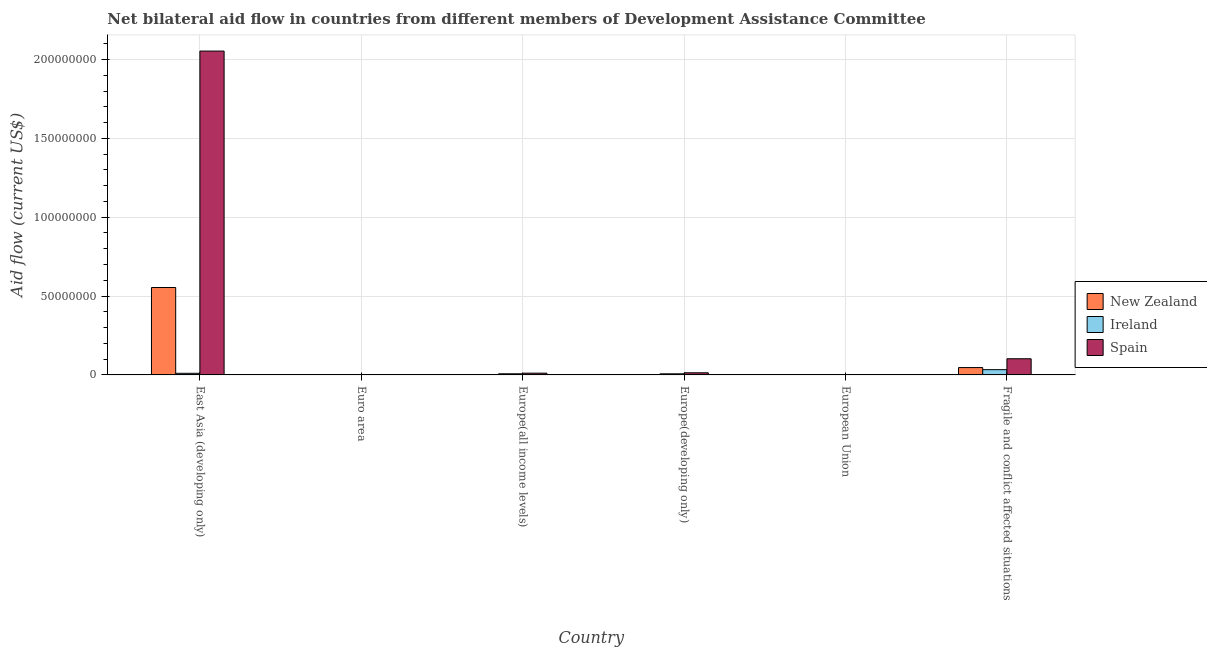How many different coloured bars are there?
Keep it short and to the point. 3. Are the number of bars per tick equal to the number of legend labels?
Make the answer very short. Yes. Are the number of bars on each tick of the X-axis equal?
Keep it short and to the point. Yes. How many bars are there on the 2nd tick from the left?
Your answer should be compact. 3. How many bars are there on the 4th tick from the right?
Ensure brevity in your answer.  3. What is the label of the 6th group of bars from the left?
Keep it short and to the point. Fragile and conflict affected situations. In how many cases, is the number of bars for a given country not equal to the number of legend labels?
Offer a very short reply. 0. What is the amount of aid provided by new zealand in Euro area?
Provide a succinct answer. 10000. Across all countries, what is the maximum amount of aid provided by new zealand?
Offer a terse response. 5.54e+07. Across all countries, what is the minimum amount of aid provided by ireland?
Make the answer very short. 3.00e+04. In which country was the amount of aid provided by new zealand maximum?
Your response must be concise. East Asia (developing only). In which country was the amount of aid provided by ireland minimum?
Provide a short and direct response. Euro area. What is the total amount of aid provided by spain in the graph?
Ensure brevity in your answer.  2.18e+08. What is the difference between the amount of aid provided by new zealand in East Asia (developing only) and that in European Union?
Provide a short and direct response. 5.54e+07. What is the difference between the amount of aid provided by ireland in Europe(developing only) and the amount of aid provided by spain in Fragile and conflict affected situations?
Your answer should be compact. -9.55e+06. What is the average amount of aid provided by new zealand per country?
Provide a succinct answer. 1.00e+07. What is the difference between the amount of aid provided by ireland and amount of aid provided by new zealand in Euro area?
Keep it short and to the point. 2.00e+04. What is the ratio of the amount of aid provided by spain in Europe(all income levels) to that in Fragile and conflict affected situations?
Offer a very short reply. 0.11. Is the amount of aid provided by ireland in European Union less than that in Fragile and conflict affected situations?
Your response must be concise. Yes. Is the difference between the amount of aid provided by spain in East Asia (developing only) and Fragile and conflict affected situations greater than the difference between the amount of aid provided by new zealand in East Asia (developing only) and Fragile and conflict affected situations?
Offer a very short reply. Yes. What is the difference between the highest and the second highest amount of aid provided by spain?
Keep it short and to the point. 1.95e+08. What is the difference between the highest and the lowest amount of aid provided by new zealand?
Offer a terse response. 5.54e+07. In how many countries, is the amount of aid provided by new zealand greater than the average amount of aid provided by new zealand taken over all countries?
Make the answer very short. 1. Is the sum of the amount of aid provided by ireland in Europe(all income levels) and Fragile and conflict affected situations greater than the maximum amount of aid provided by spain across all countries?
Provide a succinct answer. No. What does the 1st bar from the left in East Asia (developing only) represents?
Keep it short and to the point. New Zealand. What does the 3rd bar from the right in Europe(all income levels) represents?
Ensure brevity in your answer.  New Zealand. Are the values on the major ticks of Y-axis written in scientific E-notation?
Offer a terse response. No. Does the graph contain grids?
Your answer should be very brief. Yes. How many legend labels are there?
Ensure brevity in your answer.  3. What is the title of the graph?
Ensure brevity in your answer.  Net bilateral aid flow in countries from different members of Development Assistance Committee. Does "Private sector" appear as one of the legend labels in the graph?
Your answer should be compact. No. What is the Aid flow (current US$) of New Zealand in East Asia (developing only)?
Give a very brief answer. 5.54e+07. What is the Aid flow (current US$) of Ireland in East Asia (developing only)?
Provide a short and direct response. 1.02e+06. What is the Aid flow (current US$) in Spain in East Asia (developing only)?
Ensure brevity in your answer.  2.05e+08. What is the Aid flow (current US$) of Ireland in Euro area?
Ensure brevity in your answer.  3.00e+04. What is the Aid flow (current US$) of New Zealand in Europe(all income levels)?
Provide a short and direct response. 9.00e+04. What is the Aid flow (current US$) in Ireland in Europe(all income levels)?
Your answer should be compact. 7.20e+05. What is the Aid flow (current US$) of Spain in Europe(all income levels)?
Your answer should be compact. 1.11e+06. What is the Aid flow (current US$) in Ireland in Europe(developing only)?
Provide a succinct answer. 6.90e+05. What is the Aid flow (current US$) of Spain in Europe(developing only)?
Offer a terse response. 1.35e+06. What is the Aid flow (current US$) of New Zealand in European Union?
Give a very brief answer. 5.00e+04. What is the Aid flow (current US$) in New Zealand in Fragile and conflict affected situations?
Offer a very short reply. 4.66e+06. What is the Aid flow (current US$) of Ireland in Fragile and conflict affected situations?
Your answer should be very brief. 3.33e+06. What is the Aid flow (current US$) in Spain in Fragile and conflict affected situations?
Keep it short and to the point. 1.02e+07. Across all countries, what is the maximum Aid flow (current US$) in New Zealand?
Your answer should be compact. 5.54e+07. Across all countries, what is the maximum Aid flow (current US$) in Ireland?
Provide a short and direct response. 3.33e+06. Across all countries, what is the maximum Aid flow (current US$) of Spain?
Give a very brief answer. 2.05e+08. Across all countries, what is the minimum Aid flow (current US$) in Ireland?
Keep it short and to the point. 3.00e+04. Across all countries, what is the minimum Aid flow (current US$) in Spain?
Your response must be concise. 8.00e+04. What is the total Aid flow (current US$) of New Zealand in the graph?
Make the answer very short. 6.03e+07. What is the total Aid flow (current US$) of Ireland in the graph?
Give a very brief answer. 5.86e+06. What is the total Aid flow (current US$) of Spain in the graph?
Offer a terse response. 2.18e+08. What is the difference between the Aid flow (current US$) in New Zealand in East Asia (developing only) and that in Euro area?
Offer a very short reply. 5.54e+07. What is the difference between the Aid flow (current US$) in Ireland in East Asia (developing only) and that in Euro area?
Keep it short and to the point. 9.90e+05. What is the difference between the Aid flow (current US$) of Spain in East Asia (developing only) and that in Euro area?
Your response must be concise. 2.05e+08. What is the difference between the Aid flow (current US$) in New Zealand in East Asia (developing only) and that in Europe(all income levels)?
Offer a very short reply. 5.53e+07. What is the difference between the Aid flow (current US$) in Ireland in East Asia (developing only) and that in Europe(all income levels)?
Give a very brief answer. 3.00e+05. What is the difference between the Aid flow (current US$) in Spain in East Asia (developing only) and that in Europe(all income levels)?
Your answer should be very brief. 2.04e+08. What is the difference between the Aid flow (current US$) of New Zealand in East Asia (developing only) and that in Europe(developing only)?
Your answer should be very brief. 5.54e+07. What is the difference between the Aid flow (current US$) of Spain in East Asia (developing only) and that in Europe(developing only)?
Your response must be concise. 2.04e+08. What is the difference between the Aid flow (current US$) of New Zealand in East Asia (developing only) and that in European Union?
Keep it short and to the point. 5.54e+07. What is the difference between the Aid flow (current US$) in Ireland in East Asia (developing only) and that in European Union?
Your answer should be very brief. 9.50e+05. What is the difference between the Aid flow (current US$) in Spain in East Asia (developing only) and that in European Union?
Give a very brief answer. 2.05e+08. What is the difference between the Aid flow (current US$) in New Zealand in East Asia (developing only) and that in Fragile and conflict affected situations?
Your answer should be very brief. 5.08e+07. What is the difference between the Aid flow (current US$) of Ireland in East Asia (developing only) and that in Fragile and conflict affected situations?
Provide a short and direct response. -2.31e+06. What is the difference between the Aid flow (current US$) of Spain in East Asia (developing only) and that in Fragile and conflict affected situations?
Offer a very short reply. 1.95e+08. What is the difference between the Aid flow (current US$) of Ireland in Euro area and that in Europe(all income levels)?
Offer a very short reply. -6.90e+05. What is the difference between the Aid flow (current US$) of Spain in Euro area and that in Europe(all income levels)?
Make the answer very short. -9.10e+05. What is the difference between the Aid flow (current US$) of Ireland in Euro area and that in Europe(developing only)?
Offer a very short reply. -6.60e+05. What is the difference between the Aid flow (current US$) in Spain in Euro area and that in Europe(developing only)?
Your response must be concise. -1.15e+06. What is the difference between the Aid flow (current US$) of New Zealand in Euro area and that in European Union?
Your response must be concise. -4.00e+04. What is the difference between the Aid flow (current US$) of Ireland in Euro area and that in European Union?
Your answer should be compact. -4.00e+04. What is the difference between the Aid flow (current US$) of Spain in Euro area and that in European Union?
Provide a succinct answer. 1.20e+05. What is the difference between the Aid flow (current US$) in New Zealand in Euro area and that in Fragile and conflict affected situations?
Make the answer very short. -4.65e+06. What is the difference between the Aid flow (current US$) of Ireland in Euro area and that in Fragile and conflict affected situations?
Offer a very short reply. -3.30e+06. What is the difference between the Aid flow (current US$) in Spain in Euro area and that in Fragile and conflict affected situations?
Keep it short and to the point. -1.00e+07. What is the difference between the Aid flow (current US$) of Ireland in Europe(all income levels) and that in Europe(developing only)?
Your response must be concise. 3.00e+04. What is the difference between the Aid flow (current US$) of Ireland in Europe(all income levels) and that in European Union?
Make the answer very short. 6.50e+05. What is the difference between the Aid flow (current US$) of Spain in Europe(all income levels) and that in European Union?
Give a very brief answer. 1.03e+06. What is the difference between the Aid flow (current US$) of New Zealand in Europe(all income levels) and that in Fragile and conflict affected situations?
Your answer should be very brief. -4.57e+06. What is the difference between the Aid flow (current US$) of Ireland in Europe(all income levels) and that in Fragile and conflict affected situations?
Offer a terse response. -2.61e+06. What is the difference between the Aid flow (current US$) in Spain in Europe(all income levels) and that in Fragile and conflict affected situations?
Your response must be concise. -9.13e+06. What is the difference between the Aid flow (current US$) of Ireland in Europe(developing only) and that in European Union?
Your answer should be very brief. 6.20e+05. What is the difference between the Aid flow (current US$) of Spain in Europe(developing only) and that in European Union?
Provide a succinct answer. 1.27e+06. What is the difference between the Aid flow (current US$) in New Zealand in Europe(developing only) and that in Fragile and conflict affected situations?
Give a very brief answer. -4.60e+06. What is the difference between the Aid flow (current US$) in Ireland in Europe(developing only) and that in Fragile and conflict affected situations?
Offer a terse response. -2.64e+06. What is the difference between the Aid flow (current US$) of Spain in Europe(developing only) and that in Fragile and conflict affected situations?
Offer a very short reply. -8.89e+06. What is the difference between the Aid flow (current US$) in New Zealand in European Union and that in Fragile and conflict affected situations?
Keep it short and to the point. -4.61e+06. What is the difference between the Aid flow (current US$) of Ireland in European Union and that in Fragile and conflict affected situations?
Your answer should be compact. -3.26e+06. What is the difference between the Aid flow (current US$) in Spain in European Union and that in Fragile and conflict affected situations?
Keep it short and to the point. -1.02e+07. What is the difference between the Aid flow (current US$) in New Zealand in East Asia (developing only) and the Aid flow (current US$) in Ireland in Euro area?
Offer a very short reply. 5.54e+07. What is the difference between the Aid flow (current US$) in New Zealand in East Asia (developing only) and the Aid flow (current US$) in Spain in Euro area?
Make the answer very short. 5.52e+07. What is the difference between the Aid flow (current US$) of Ireland in East Asia (developing only) and the Aid flow (current US$) of Spain in Euro area?
Provide a succinct answer. 8.20e+05. What is the difference between the Aid flow (current US$) in New Zealand in East Asia (developing only) and the Aid flow (current US$) in Ireland in Europe(all income levels)?
Offer a very short reply. 5.47e+07. What is the difference between the Aid flow (current US$) in New Zealand in East Asia (developing only) and the Aid flow (current US$) in Spain in Europe(all income levels)?
Your answer should be compact. 5.43e+07. What is the difference between the Aid flow (current US$) in New Zealand in East Asia (developing only) and the Aid flow (current US$) in Ireland in Europe(developing only)?
Keep it short and to the point. 5.47e+07. What is the difference between the Aid flow (current US$) in New Zealand in East Asia (developing only) and the Aid flow (current US$) in Spain in Europe(developing only)?
Provide a short and direct response. 5.41e+07. What is the difference between the Aid flow (current US$) in Ireland in East Asia (developing only) and the Aid flow (current US$) in Spain in Europe(developing only)?
Keep it short and to the point. -3.30e+05. What is the difference between the Aid flow (current US$) in New Zealand in East Asia (developing only) and the Aid flow (current US$) in Ireland in European Union?
Provide a succinct answer. 5.54e+07. What is the difference between the Aid flow (current US$) of New Zealand in East Asia (developing only) and the Aid flow (current US$) of Spain in European Union?
Offer a very short reply. 5.54e+07. What is the difference between the Aid flow (current US$) of Ireland in East Asia (developing only) and the Aid flow (current US$) of Spain in European Union?
Offer a terse response. 9.40e+05. What is the difference between the Aid flow (current US$) of New Zealand in East Asia (developing only) and the Aid flow (current US$) of Ireland in Fragile and conflict affected situations?
Offer a very short reply. 5.21e+07. What is the difference between the Aid flow (current US$) in New Zealand in East Asia (developing only) and the Aid flow (current US$) in Spain in Fragile and conflict affected situations?
Provide a short and direct response. 4.52e+07. What is the difference between the Aid flow (current US$) of Ireland in East Asia (developing only) and the Aid flow (current US$) of Spain in Fragile and conflict affected situations?
Your answer should be very brief. -9.22e+06. What is the difference between the Aid flow (current US$) of New Zealand in Euro area and the Aid flow (current US$) of Ireland in Europe(all income levels)?
Ensure brevity in your answer.  -7.10e+05. What is the difference between the Aid flow (current US$) of New Zealand in Euro area and the Aid flow (current US$) of Spain in Europe(all income levels)?
Give a very brief answer. -1.10e+06. What is the difference between the Aid flow (current US$) in Ireland in Euro area and the Aid flow (current US$) in Spain in Europe(all income levels)?
Keep it short and to the point. -1.08e+06. What is the difference between the Aid flow (current US$) in New Zealand in Euro area and the Aid flow (current US$) in Ireland in Europe(developing only)?
Offer a very short reply. -6.80e+05. What is the difference between the Aid flow (current US$) of New Zealand in Euro area and the Aid flow (current US$) of Spain in Europe(developing only)?
Your answer should be compact. -1.34e+06. What is the difference between the Aid flow (current US$) in Ireland in Euro area and the Aid flow (current US$) in Spain in Europe(developing only)?
Provide a succinct answer. -1.32e+06. What is the difference between the Aid flow (current US$) of New Zealand in Euro area and the Aid flow (current US$) of Spain in European Union?
Your response must be concise. -7.00e+04. What is the difference between the Aid flow (current US$) of New Zealand in Euro area and the Aid flow (current US$) of Ireland in Fragile and conflict affected situations?
Ensure brevity in your answer.  -3.32e+06. What is the difference between the Aid flow (current US$) in New Zealand in Euro area and the Aid flow (current US$) in Spain in Fragile and conflict affected situations?
Keep it short and to the point. -1.02e+07. What is the difference between the Aid flow (current US$) of Ireland in Euro area and the Aid flow (current US$) of Spain in Fragile and conflict affected situations?
Give a very brief answer. -1.02e+07. What is the difference between the Aid flow (current US$) of New Zealand in Europe(all income levels) and the Aid flow (current US$) of Ireland in Europe(developing only)?
Your answer should be very brief. -6.00e+05. What is the difference between the Aid flow (current US$) of New Zealand in Europe(all income levels) and the Aid flow (current US$) of Spain in Europe(developing only)?
Ensure brevity in your answer.  -1.26e+06. What is the difference between the Aid flow (current US$) of Ireland in Europe(all income levels) and the Aid flow (current US$) of Spain in Europe(developing only)?
Offer a very short reply. -6.30e+05. What is the difference between the Aid flow (current US$) of New Zealand in Europe(all income levels) and the Aid flow (current US$) of Ireland in European Union?
Offer a terse response. 2.00e+04. What is the difference between the Aid flow (current US$) of Ireland in Europe(all income levels) and the Aid flow (current US$) of Spain in European Union?
Your response must be concise. 6.40e+05. What is the difference between the Aid flow (current US$) of New Zealand in Europe(all income levels) and the Aid flow (current US$) of Ireland in Fragile and conflict affected situations?
Give a very brief answer. -3.24e+06. What is the difference between the Aid flow (current US$) of New Zealand in Europe(all income levels) and the Aid flow (current US$) of Spain in Fragile and conflict affected situations?
Give a very brief answer. -1.02e+07. What is the difference between the Aid flow (current US$) of Ireland in Europe(all income levels) and the Aid flow (current US$) of Spain in Fragile and conflict affected situations?
Your response must be concise. -9.52e+06. What is the difference between the Aid flow (current US$) of New Zealand in Europe(developing only) and the Aid flow (current US$) of Ireland in European Union?
Your answer should be compact. -10000. What is the difference between the Aid flow (current US$) in New Zealand in Europe(developing only) and the Aid flow (current US$) in Spain in European Union?
Your response must be concise. -2.00e+04. What is the difference between the Aid flow (current US$) of New Zealand in Europe(developing only) and the Aid flow (current US$) of Ireland in Fragile and conflict affected situations?
Give a very brief answer. -3.27e+06. What is the difference between the Aid flow (current US$) of New Zealand in Europe(developing only) and the Aid flow (current US$) of Spain in Fragile and conflict affected situations?
Provide a short and direct response. -1.02e+07. What is the difference between the Aid flow (current US$) in Ireland in Europe(developing only) and the Aid flow (current US$) in Spain in Fragile and conflict affected situations?
Your answer should be very brief. -9.55e+06. What is the difference between the Aid flow (current US$) in New Zealand in European Union and the Aid flow (current US$) in Ireland in Fragile and conflict affected situations?
Offer a terse response. -3.28e+06. What is the difference between the Aid flow (current US$) in New Zealand in European Union and the Aid flow (current US$) in Spain in Fragile and conflict affected situations?
Make the answer very short. -1.02e+07. What is the difference between the Aid flow (current US$) in Ireland in European Union and the Aid flow (current US$) in Spain in Fragile and conflict affected situations?
Provide a succinct answer. -1.02e+07. What is the average Aid flow (current US$) in New Zealand per country?
Offer a very short reply. 1.00e+07. What is the average Aid flow (current US$) in Ireland per country?
Your answer should be compact. 9.77e+05. What is the average Aid flow (current US$) in Spain per country?
Provide a succinct answer. 3.64e+07. What is the difference between the Aid flow (current US$) in New Zealand and Aid flow (current US$) in Ireland in East Asia (developing only)?
Keep it short and to the point. 5.44e+07. What is the difference between the Aid flow (current US$) in New Zealand and Aid flow (current US$) in Spain in East Asia (developing only)?
Offer a terse response. -1.50e+08. What is the difference between the Aid flow (current US$) of Ireland and Aid flow (current US$) of Spain in East Asia (developing only)?
Ensure brevity in your answer.  -2.04e+08. What is the difference between the Aid flow (current US$) in New Zealand and Aid flow (current US$) in Spain in Euro area?
Keep it short and to the point. -1.90e+05. What is the difference between the Aid flow (current US$) in Ireland and Aid flow (current US$) in Spain in Euro area?
Offer a very short reply. -1.70e+05. What is the difference between the Aid flow (current US$) in New Zealand and Aid flow (current US$) in Ireland in Europe(all income levels)?
Keep it short and to the point. -6.30e+05. What is the difference between the Aid flow (current US$) of New Zealand and Aid flow (current US$) of Spain in Europe(all income levels)?
Your response must be concise. -1.02e+06. What is the difference between the Aid flow (current US$) in Ireland and Aid flow (current US$) in Spain in Europe(all income levels)?
Your answer should be very brief. -3.90e+05. What is the difference between the Aid flow (current US$) in New Zealand and Aid flow (current US$) in Ireland in Europe(developing only)?
Offer a very short reply. -6.30e+05. What is the difference between the Aid flow (current US$) in New Zealand and Aid flow (current US$) in Spain in Europe(developing only)?
Offer a terse response. -1.29e+06. What is the difference between the Aid flow (current US$) of Ireland and Aid flow (current US$) of Spain in Europe(developing only)?
Give a very brief answer. -6.60e+05. What is the difference between the Aid flow (current US$) in New Zealand and Aid flow (current US$) in Ireland in European Union?
Give a very brief answer. -2.00e+04. What is the difference between the Aid flow (current US$) in New Zealand and Aid flow (current US$) in Ireland in Fragile and conflict affected situations?
Give a very brief answer. 1.33e+06. What is the difference between the Aid flow (current US$) of New Zealand and Aid flow (current US$) of Spain in Fragile and conflict affected situations?
Provide a short and direct response. -5.58e+06. What is the difference between the Aid flow (current US$) in Ireland and Aid flow (current US$) in Spain in Fragile and conflict affected situations?
Keep it short and to the point. -6.91e+06. What is the ratio of the Aid flow (current US$) of New Zealand in East Asia (developing only) to that in Euro area?
Ensure brevity in your answer.  5543. What is the ratio of the Aid flow (current US$) in Ireland in East Asia (developing only) to that in Euro area?
Offer a very short reply. 34. What is the ratio of the Aid flow (current US$) of Spain in East Asia (developing only) to that in Euro area?
Make the answer very short. 1026.8. What is the ratio of the Aid flow (current US$) in New Zealand in East Asia (developing only) to that in Europe(all income levels)?
Offer a terse response. 615.89. What is the ratio of the Aid flow (current US$) of Ireland in East Asia (developing only) to that in Europe(all income levels)?
Your answer should be very brief. 1.42. What is the ratio of the Aid flow (current US$) in Spain in East Asia (developing only) to that in Europe(all income levels)?
Your response must be concise. 185.01. What is the ratio of the Aid flow (current US$) of New Zealand in East Asia (developing only) to that in Europe(developing only)?
Provide a succinct answer. 923.83. What is the ratio of the Aid flow (current US$) of Ireland in East Asia (developing only) to that in Europe(developing only)?
Provide a succinct answer. 1.48. What is the ratio of the Aid flow (current US$) of Spain in East Asia (developing only) to that in Europe(developing only)?
Your answer should be compact. 152.12. What is the ratio of the Aid flow (current US$) of New Zealand in East Asia (developing only) to that in European Union?
Your response must be concise. 1108.6. What is the ratio of the Aid flow (current US$) of Ireland in East Asia (developing only) to that in European Union?
Provide a short and direct response. 14.57. What is the ratio of the Aid flow (current US$) of Spain in East Asia (developing only) to that in European Union?
Offer a terse response. 2567. What is the ratio of the Aid flow (current US$) of New Zealand in East Asia (developing only) to that in Fragile and conflict affected situations?
Your answer should be very brief. 11.89. What is the ratio of the Aid flow (current US$) of Ireland in East Asia (developing only) to that in Fragile and conflict affected situations?
Offer a very short reply. 0.31. What is the ratio of the Aid flow (current US$) in Spain in East Asia (developing only) to that in Fragile and conflict affected situations?
Ensure brevity in your answer.  20.05. What is the ratio of the Aid flow (current US$) in New Zealand in Euro area to that in Europe(all income levels)?
Offer a terse response. 0.11. What is the ratio of the Aid flow (current US$) of Ireland in Euro area to that in Europe(all income levels)?
Your answer should be very brief. 0.04. What is the ratio of the Aid flow (current US$) of Spain in Euro area to that in Europe(all income levels)?
Provide a succinct answer. 0.18. What is the ratio of the Aid flow (current US$) in Ireland in Euro area to that in Europe(developing only)?
Offer a very short reply. 0.04. What is the ratio of the Aid flow (current US$) in Spain in Euro area to that in Europe(developing only)?
Your response must be concise. 0.15. What is the ratio of the Aid flow (current US$) in Ireland in Euro area to that in European Union?
Keep it short and to the point. 0.43. What is the ratio of the Aid flow (current US$) of New Zealand in Euro area to that in Fragile and conflict affected situations?
Keep it short and to the point. 0. What is the ratio of the Aid flow (current US$) in Ireland in Euro area to that in Fragile and conflict affected situations?
Provide a succinct answer. 0.01. What is the ratio of the Aid flow (current US$) in Spain in Euro area to that in Fragile and conflict affected situations?
Your answer should be compact. 0.02. What is the ratio of the Aid flow (current US$) of Ireland in Europe(all income levels) to that in Europe(developing only)?
Your answer should be compact. 1.04. What is the ratio of the Aid flow (current US$) in Spain in Europe(all income levels) to that in Europe(developing only)?
Give a very brief answer. 0.82. What is the ratio of the Aid flow (current US$) in Ireland in Europe(all income levels) to that in European Union?
Ensure brevity in your answer.  10.29. What is the ratio of the Aid flow (current US$) in Spain in Europe(all income levels) to that in European Union?
Ensure brevity in your answer.  13.88. What is the ratio of the Aid flow (current US$) in New Zealand in Europe(all income levels) to that in Fragile and conflict affected situations?
Provide a succinct answer. 0.02. What is the ratio of the Aid flow (current US$) of Ireland in Europe(all income levels) to that in Fragile and conflict affected situations?
Provide a short and direct response. 0.22. What is the ratio of the Aid flow (current US$) of Spain in Europe(all income levels) to that in Fragile and conflict affected situations?
Ensure brevity in your answer.  0.11. What is the ratio of the Aid flow (current US$) of Ireland in Europe(developing only) to that in European Union?
Provide a short and direct response. 9.86. What is the ratio of the Aid flow (current US$) of Spain in Europe(developing only) to that in European Union?
Ensure brevity in your answer.  16.88. What is the ratio of the Aid flow (current US$) in New Zealand in Europe(developing only) to that in Fragile and conflict affected situations?
Give a very brief answer. 0.01. What is the ratio of the Aid flow (current US$) of Ireland in Europe(developing only) to that in Fragile and conflict affected situations?
Your response must be concise. 0.21. What is the ratio of the Aid flow (current US$) in Spain in Europe(developing only) to that in Fragile and conflict affected situations?
Keep it short and to the point. 0.13. What is the ratio of the Aid flow (current US$) of New Zealand in European Union to that in Fragile and conflict affected situations?
Provide a succinct answer. 0.01. What is the ratio of the Aid flow (current US$) in Ireland in European Union to that in Fragile and conflict affected situations?
Keep it short and to the point. 0.02. What is the ratio of the Aid flow (current US$) in Spain in European Union to that in Fragile and conflict affected situations?
Make the answer very short. 0.01. What is the difference between the highest and the second highest Aid flow (current US$) in New Zealand?
Provide a short and direct response. 5.08e+07. What is the difference between the highest and the second highest Aid flow (current US$) of Ireland?
Your answer should be very brief. 2.31e+06. What is the difference between the highest and the second highest Aid flow (current US$) of Spain?
Offer a terse response. 1.95e+08. What is the difference between the highest and the lowest Aid flow (current US$) of New Zealand?
Ensure brevity in your answer.  5.54e+07. What is the difference between the highest and the lowest Aid flow (current US$) of Ireland?
Provide a short and direct response. 3.30e+06. What is the difference between the highest and the lowest Aid flow (current US$) in Spain?
Ensure brevity in your answer.  2.05e+08. 